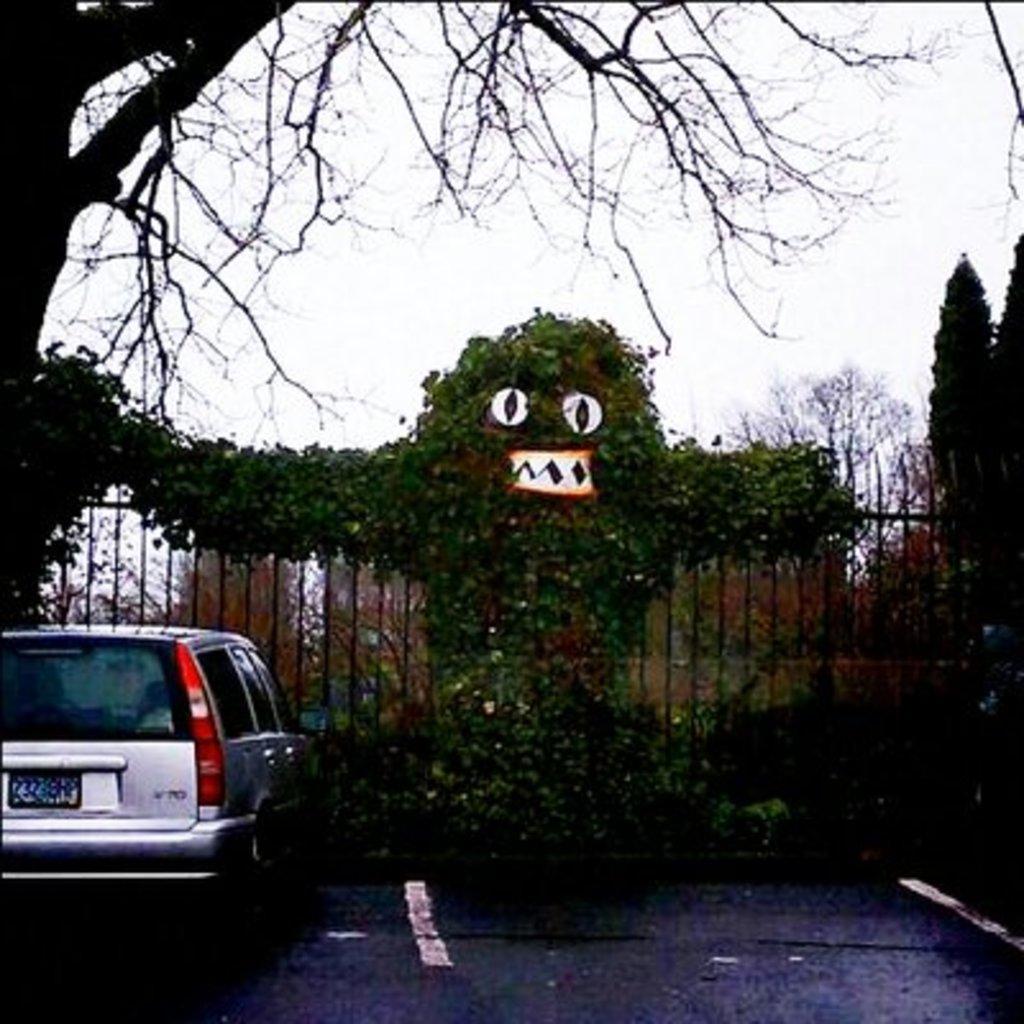Please provide a concise description of this image. On the left side of the image we can see a car on the road, in front of the car we can find few trees, metal rods and plants. 